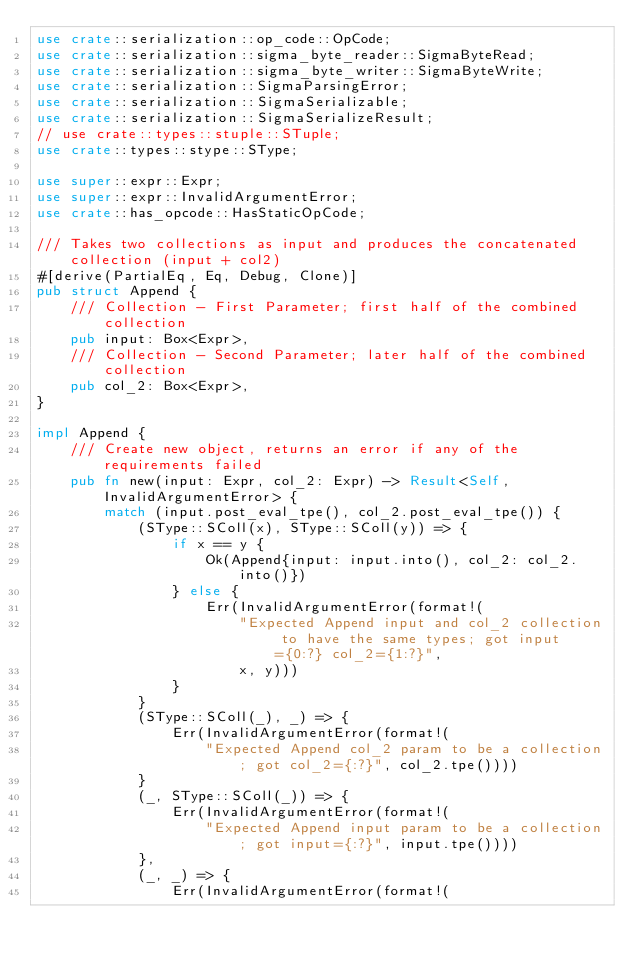<code> <loc_0><loc_0><loc_500><loc_500><_Rust_>use crate::serialization::op_code::OpCode;
use crate::serialization::sigma_byte_reader::SigmaByteRead;
use crate::serialization::sigma_byte_writer::SigmaByteWrite;
use crate::serialization::SigmaParsingError;
use crate::serialization::SigmaSerializable;
use crate::serialization::SigmaSerializeResult;
// use crate::types::stuple::STuple;
use crate::types::stype::SType;

use super::expr::Expr;
use super::expr::InvalidArgumentError;
use crate::has_opcode::HasStaticOpCode;

/// Takes two collections as input and produces the concatenated collection (input + col2)
#[derive(PartialEq, Eq, Debug, Clone)]
pub struct Append {
    /// Collection - First Parameter; first half of the combined collection
    pub input: Box<Expr>,
    /// Collection - Second Parameter; later half of the combined collection
    pub col_2: Box<Expr>,
}

impl Append {
    /// Create new object, returns an error if any of the requirements failed
    pub fn new(input: Expr, col_2: Expr) -> Result<Self, InvalidArgumentError> {
        match (input.post_eval_tpe(), col_2.post_eval_tpe()) {
            (SType::SColl(x), SType::SColl(y)) => {
                if x == y {
                    Ok(Append{input: input.into(), col_2: col_2.into()})
                } else {
                    Err(InvalidArgumentError(format!(
                        "Expected Append input and col_2 collection to have the same types; got input={0:?} col_2={1:?}",
                        x, y)))
                }
            }
            (SType::SColl(_), _) => {
                Err(InvalidArgumentError(format!(
                    "Expected Append col_2 param to be a collection; got col_2={:?}", col_2.tpe())))
            }
            (_, SType::SColl(_)) => {
                Err(InvalidArgumentError(format!(
                    "Expected Append input param to be a collection; got input={:?}", input.tpe())))   
            },
            (_, _) => {
                Err(InvalidArgumentError(format!(</code> 